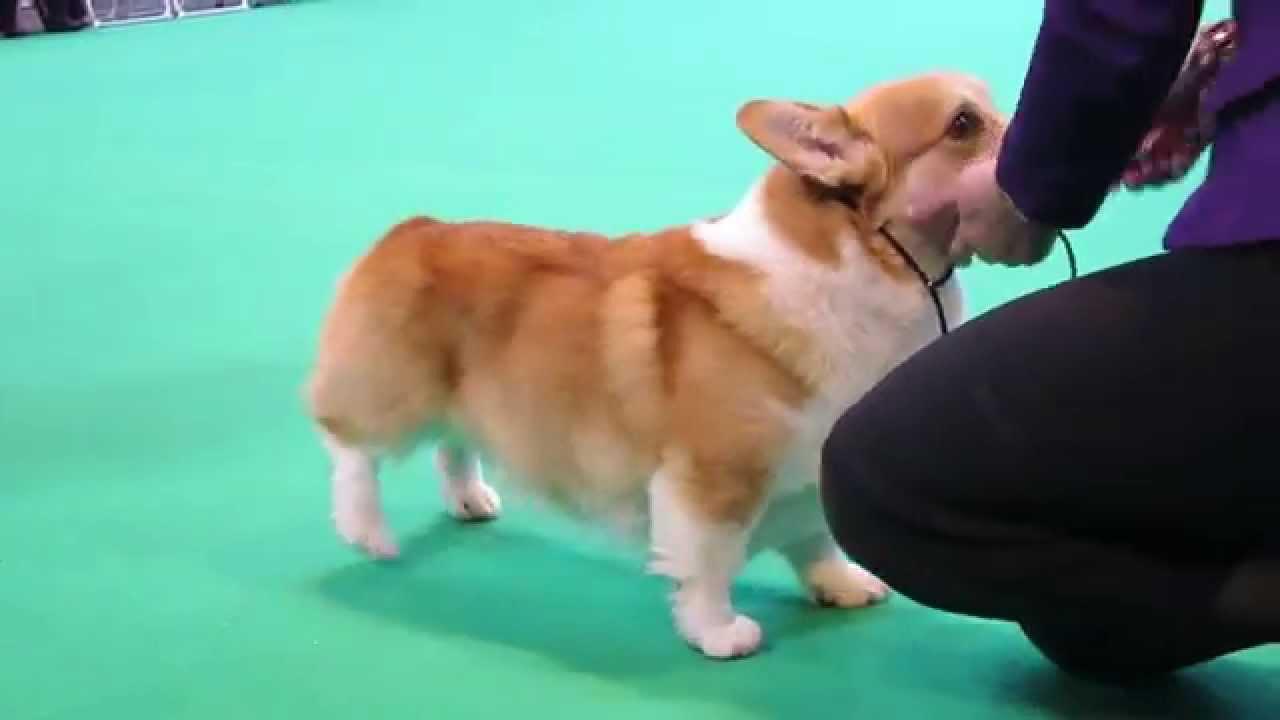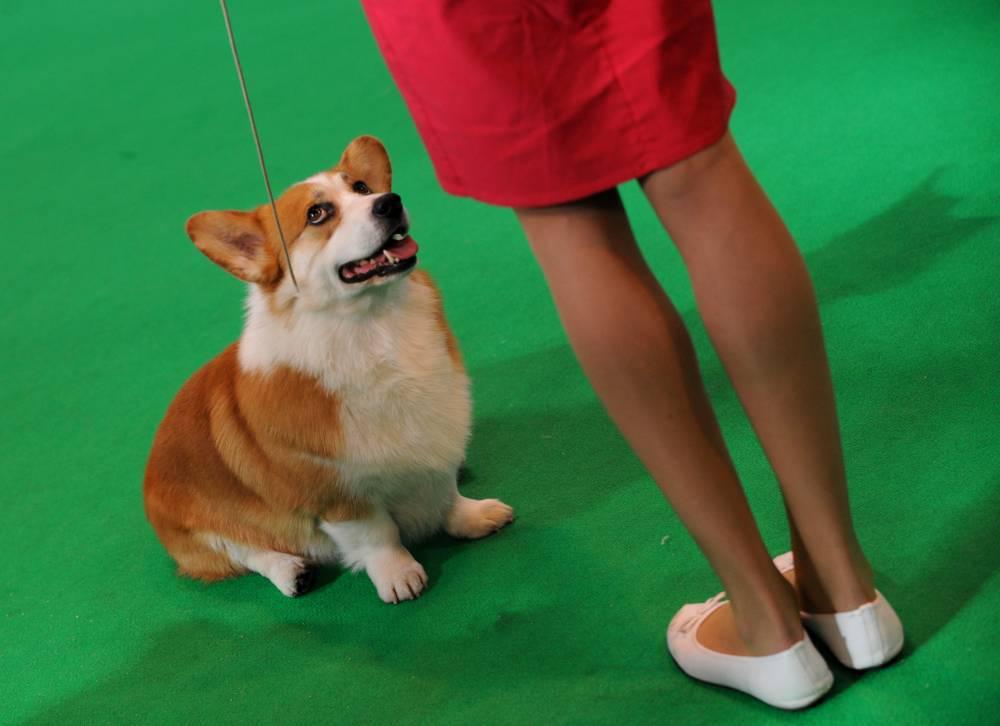The first image is the image on the left, the second image is the image on the right. For the images displayed, is the sentence "In one image, a prize ribbon is in front of a left-facing orange-and-white corgi standing on a green surface." factually correct? Answer yes or no. No. The first image is the image on the left, the second image is the image on the right. For the images displayed, is the sentence "The dog in one of the images is standing on a small step placed on the floor." factually correct? Answer yes or no. No. 